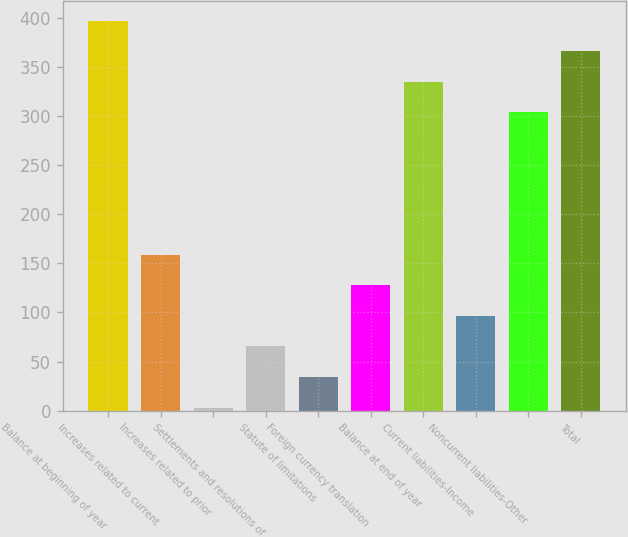Convert chart. <chart><loc_0><loc_0><loc_500><loc_500><bar_chart><fcel>Balance at beginning of year<fcel>Increases related to current<fcel>Increases related to prior<fcel>Settlements and resolutions of<fcel>Statute of limitations<fcel>Foreign currency translation<fcel>Balance at end of year<fcel>Current liabilities-Income<fcel>Noncurrent liabilities-Other<fcel>Total<nl><fcel>397.6<fcel>159<fcel>3<fcel>65.4<fcel>34.2<fcel>127.8<fcel>335.2<fcel>96.6<fcel>304<fcel>366.4<nl></chart> 